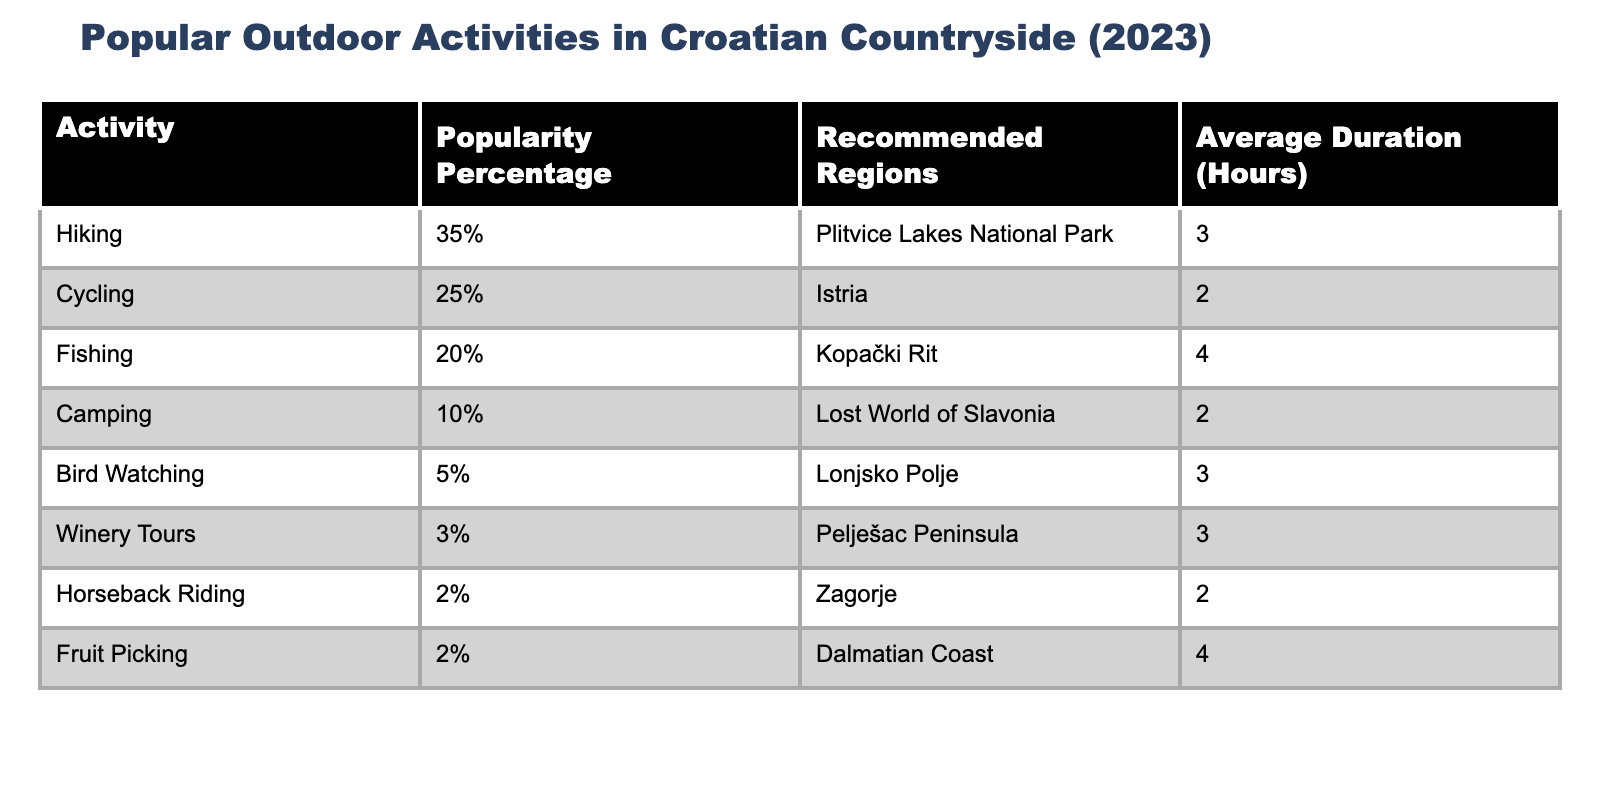What is the most popular outdoor activity in the Croatian countryside? According to the table, hiking has the highest popularity percentage at 35%.
Answer: Hiking How long, on average, do people spend on winery tours? The table shows that winery tours have an average duration of 3 hours.
Answer: 3 hours What is the popularity percentage of camping in the Croatian countryside? The table states that camping has a popularity percentage of 10%.
Answer: 10% How many outdoor activities have a popularity percentage of less than 5%? The table lists two activities: winery tours (3%) and horseback riding (2%), so there are 2 activities with less than 5% popularity.
Answer: 2 What is the average duration of fruit picking? The duration for fruit picking listed in the table is 4 hours.
Answer: 4 hours If you wanted to spend the entire day (12 hours) doing outdoor activities, how many activities could you participate in, based on their average durations? Adding the average durations of the activities: Hiking (3) + Cycling (2) + Fishing (4) + Camping (2) + Bird Watching (3) + Winery Tours (3) + Horseback Riding (2) + Fruit Picking (4), gives us a total of 23 hours. You can participate in 4 activities within 12 hours: Hiking (3), Cycling (2), Fishing (4), and Camping (2), creating overlapping times that fit in a day.
Answer: 4 activities Which region is recommended for fishing, and how long is the activity? Fishing is recommended in Kopački Rit with an average duration of 4 hours.
Answer: Kopački Rit, 4 hours Is it true that biking is as popular as camping? The table shows biking has a popularity percentage of 25%, while camping has 10%, so it's not true that they are equally popular.
Answer: No What is the total popularity percentage of hiking and cycling combined? The table indicates hiking (35%) and cycling (25%), so adding them gives 35 + 25 = 60%.
Answer: 60% How does the average duration of bird watching compare to that of cycling? Bird watching has an average duration of 3 hours, while cycling has an average duration of 2 hours. Therefore, bird watching is longer by 1 hour.
Answer: Bird watching is longer by 1 hour 